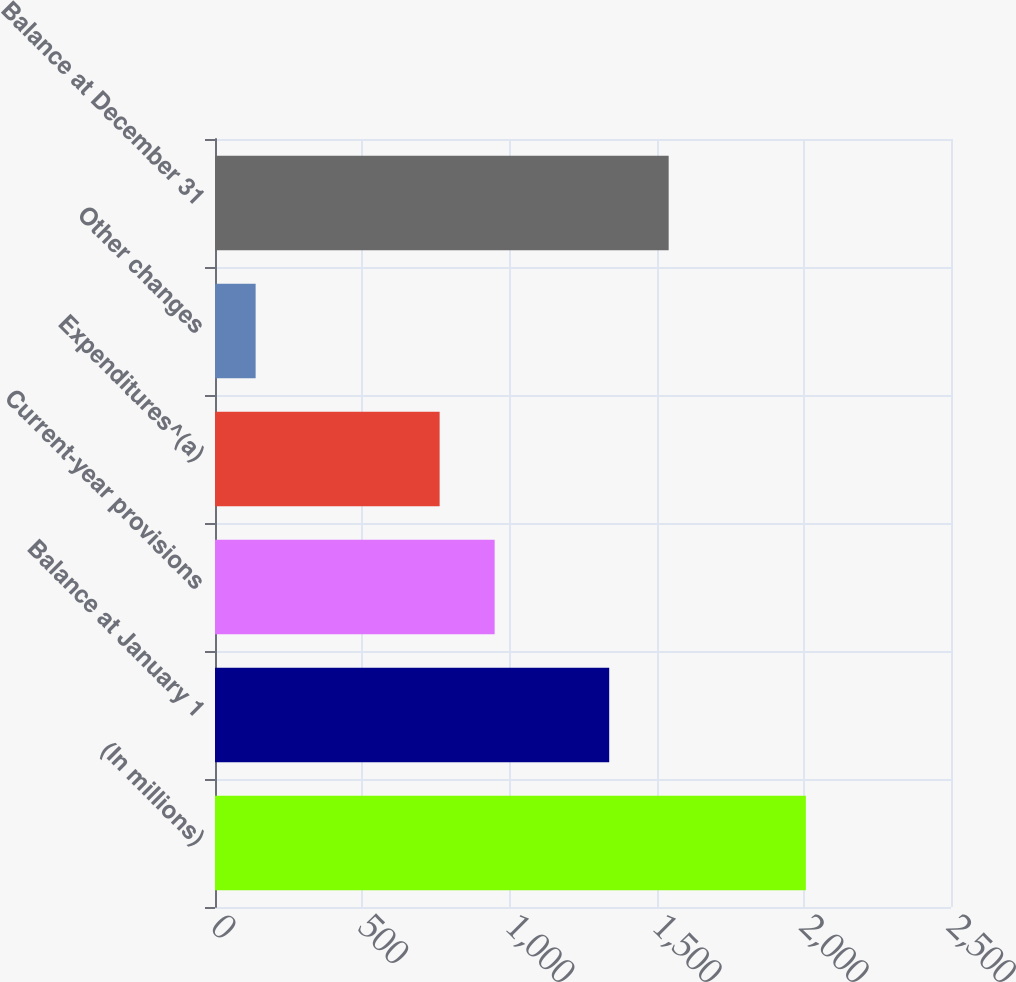Convert chart. <chart><loc_0><loc_0><loc_500><loc_500><bar_chart><fcel>(In millions)<fcel>Balance at January 1<fcel>Current-year provisions<fcel>Expenditures^(a)<fcel>Other changes<fcel>Balance at December 31<nl><fcel>2007<fcel>1339<fcel>949.9<fcel>763<fcel>138<fcel>1541<nl></chart> 